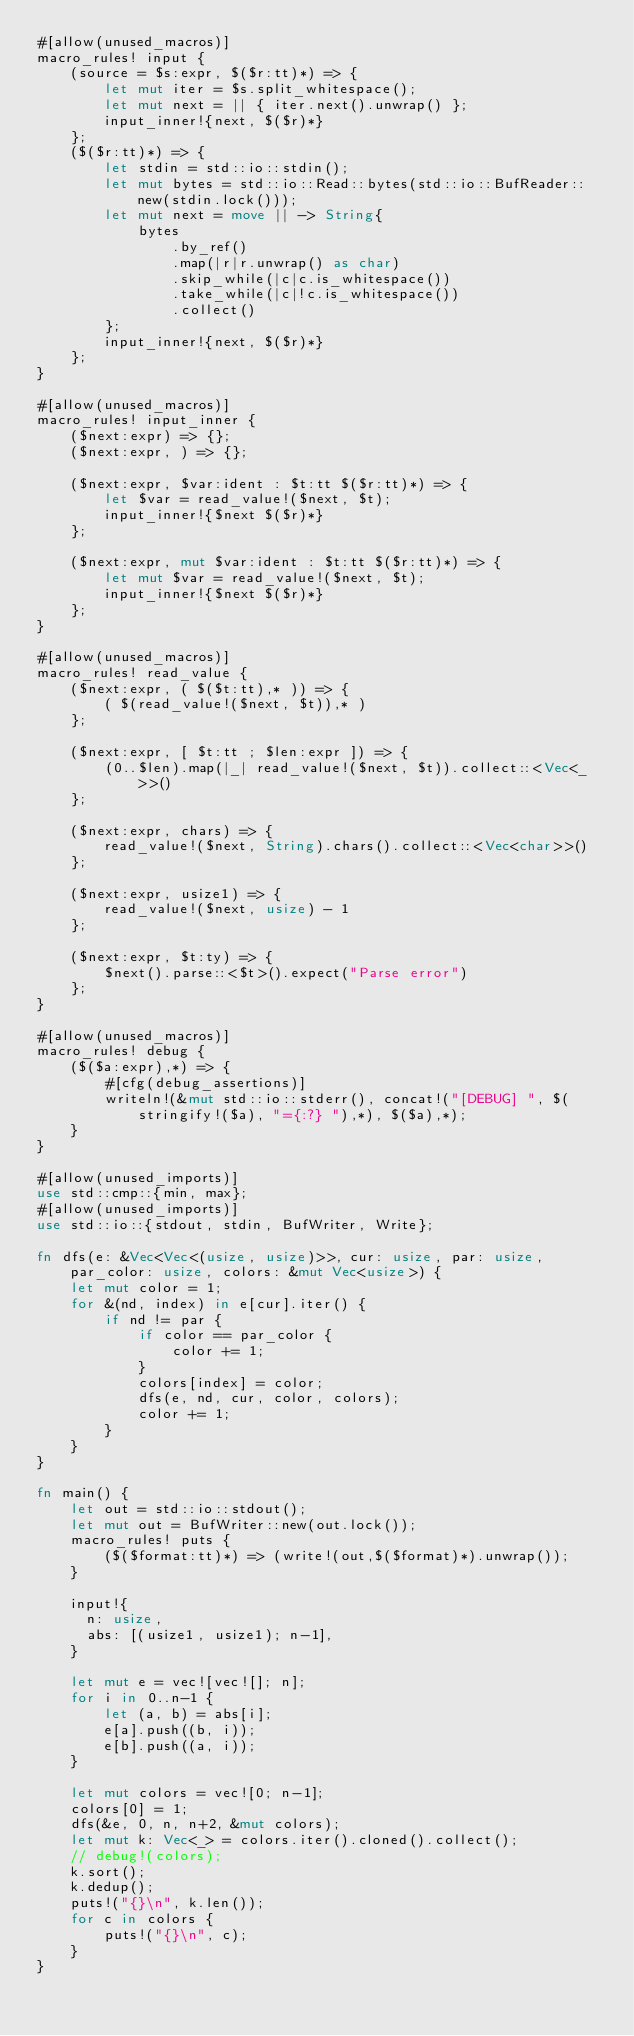Convert code to text. <code><loc_0><loc_0><loc_500><loc_500><_Rust_>#[allow(unused_macros)]
macro_rules! input {
    (source = $s:expr, $($r:tt)*) => {
        let mut iter = $s.split_whitespace();
        let mut next = || { iter.next().unwrap() };
        input_inner!{next, $($r)*}
    };
    ($($r:tt)*) => {
        let stdin = std::io::stdin();
        let mut bytes = std::io::Read::bytes(std::io::BufReader::new(stdin.lock()));
        let mut next = move || -> String{
            bytes
                .by_ref()
                .map(|r|r.unwrap() as char)
                .skip_while(|c|c.is_whitespace())
                .take_while(|c|!c.is_whitespace())
                .collect()
        };
        input_inner!{next, $($r)*}
    };
}

#[allow(unused_macros)]
macro_rules! input_inner {
    ($next:expr) => {};
    ($next:expr, ) => {};

    ($next:expr, $var:ident : $t:tt $($r:tt)*) => {
        let $var = read_value!($next, $t);
        input_inner!{$next $($r)*}
    };

    ($next:expr, mut $var:ident : $t:tt $($r:tt)*) => {
        let mut $var = read_value!($next, $t);
        input_inner!{$next $($r)*}
    };
}

#[allow(unused_macros)]
macro_rules! read_value {
    ($next:expr, ( $($t:tt),* )) => {
        ( $(read_value!($next, $t)),* )
    };

    ($next:expr, [ $t:tt ; $len:expr ]) => {
        (0..$len).map(|_| read_value!($next, $t)).collect::<Vec<_>>()
    };

    ($next:expr, chars) => {
        read_value!($next, String).chars().collect::<Vec<char>>()
    };

    ($next:expr, usize1) => {
        read_value!($next, usize) - 1
    };

    ($next:expr, $t:ty) => {
        $next().parse::<$t>().expect("Parse error")
    };
}

#[allow(unused_macros)]
macro_rules! debug {
    ($($a:expr),*) => {
        #[cfg(debug_assertions)]
        writeln!(&mut std::io::stderr(), concat!("[DEBUG] ", $(stringify!($a), "={:?} "),*), $($a),*);
    }
}

#[allow(unused_imports)]
use std::cmp::{min, max};
#[allow(unused_imports)]
use std::io::{stdout, stdin, BufWriter, Write};

fn dfs(e: &Vec<Vec<(usize, usize)>>, cur: usize, par: usize, par_color: usize, colors: &mut Vec<usize>) {
    let mut color = 1;
    for &(nd, index) in e[cur].iter() {
        if nd != par {
            if color == par_color {
                color += 1;
            }
            colors[index] = color;
            dfs(e, nd, cur, color, colors);
            color += 1;
        }
    }
}

fn main() {
    let out = std::io::stdout();
    let mut out = BufWriter::new(out.lock());
    macro_rules! puts {
        ($($format:tt)*) => (write!(out,$($format)*).unwrap());
    }

    input!{
      n: usize,
      abs: [(usize1, usize1); n-1],
    }

    let mut e = vec![vec![]; n];
    for i in 0..n-1 {
        let (a, b) = abs[i];
        e[a].push((b, i));
        e[b].push((a, i));
    }

    let mut colors = vec![0; n-1];
    colors[0] = 1;
    dfs(&e, 0, n, n+2, &mut colors);
    let mut k: Vec<_> = colors.iter().cloned().collect();
    // debug!(colors);
    k.sort();
    k.dedup();
    puts!("{}\n", k.len());
    for c in colors {
        puts!("{}\n", c);
    }
}
</code> 